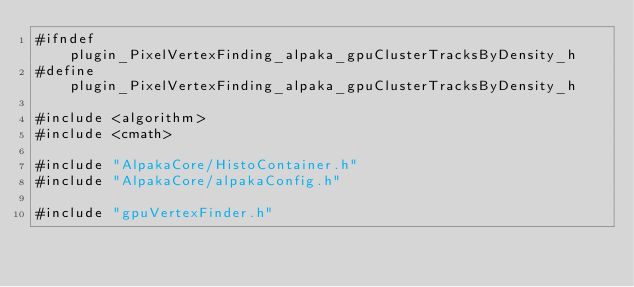Convert code to text. <code><loc_0><loc_0><loc_500><loc_500><_C_>#ifndef plugin_PixelVertexFinding_alpaka_gpuClusterTracksByDensity_h
#define plugin_PixelVertexFinding_alpaka_gpuClusterTracksByDensity_h

#include <algorithm>
#include <cmath>

#include "AlpakaCore/HistoContainer.h"
#include "AlpakaCore/alpakaConfig.h"

#include "gpuVertexFinder.h"
</code> 